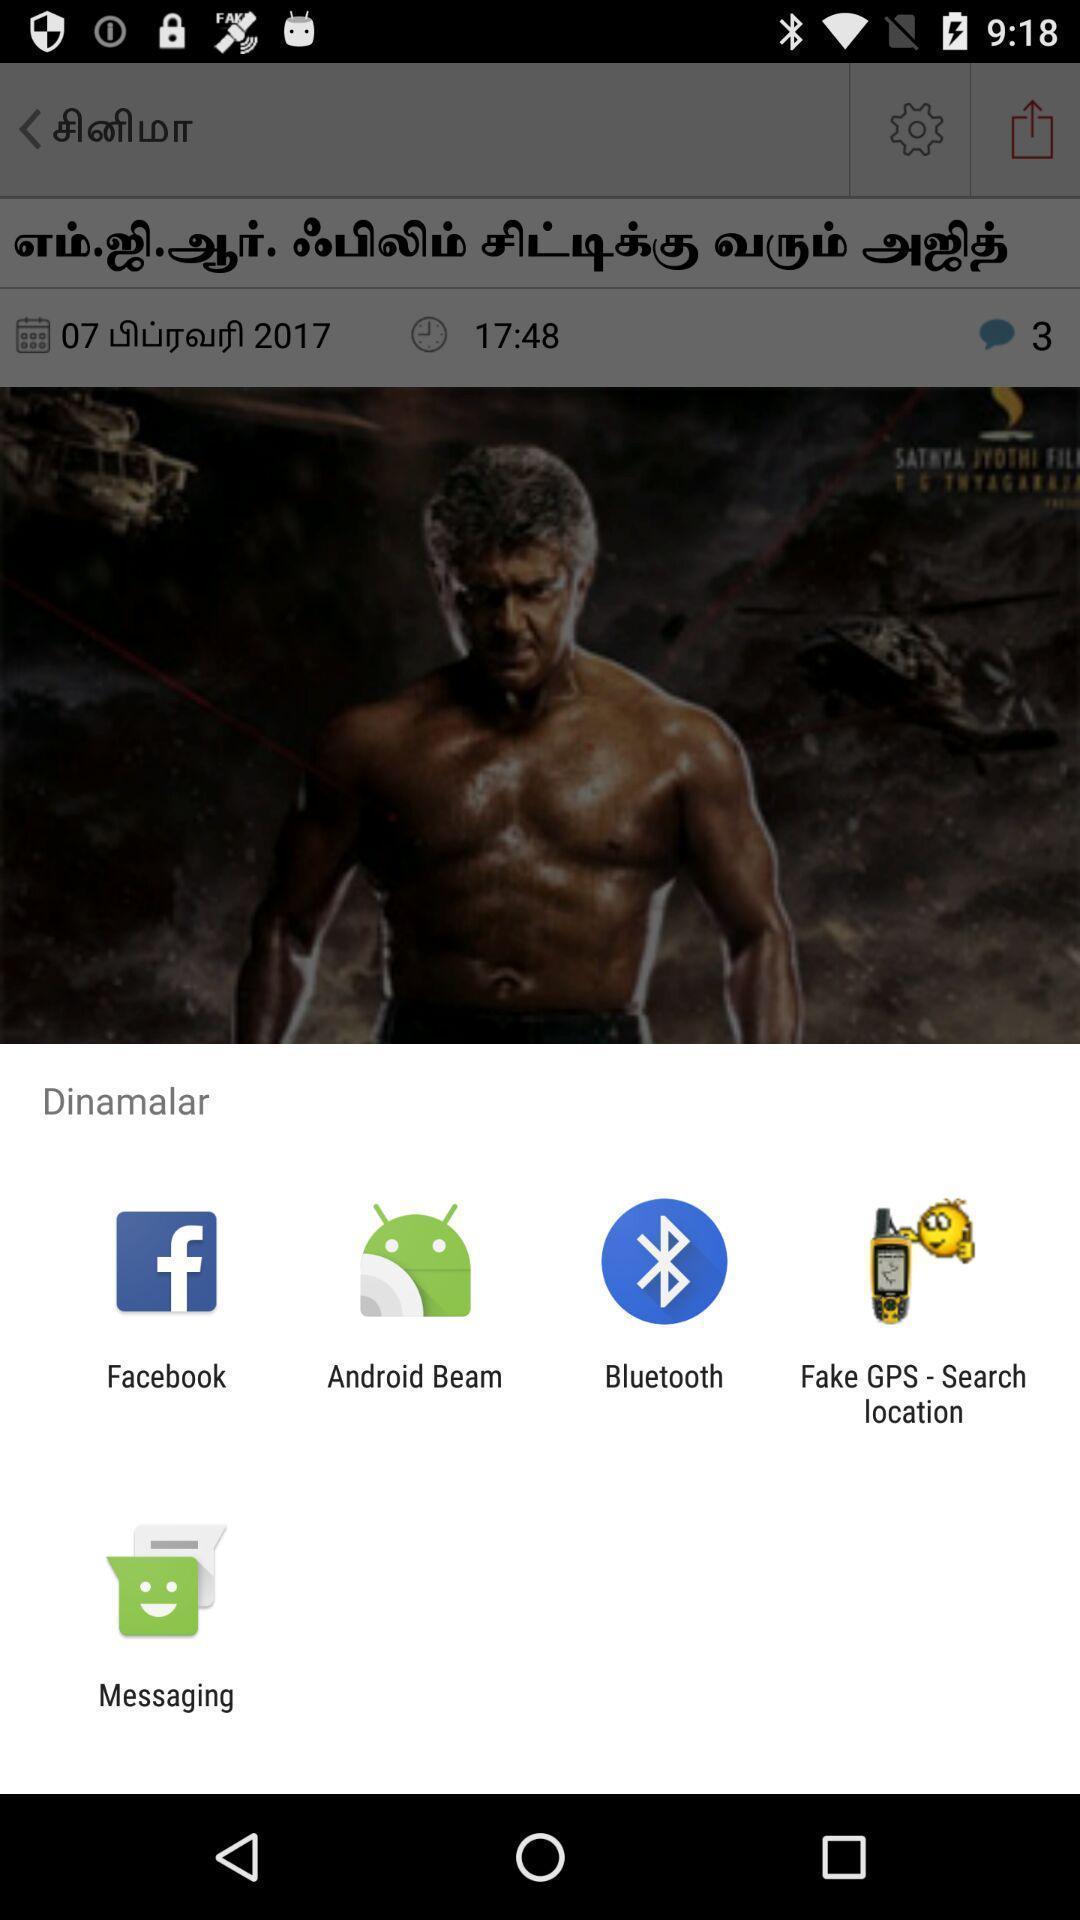Describe this image in words. Pop-up displaying the multiple social app options. 